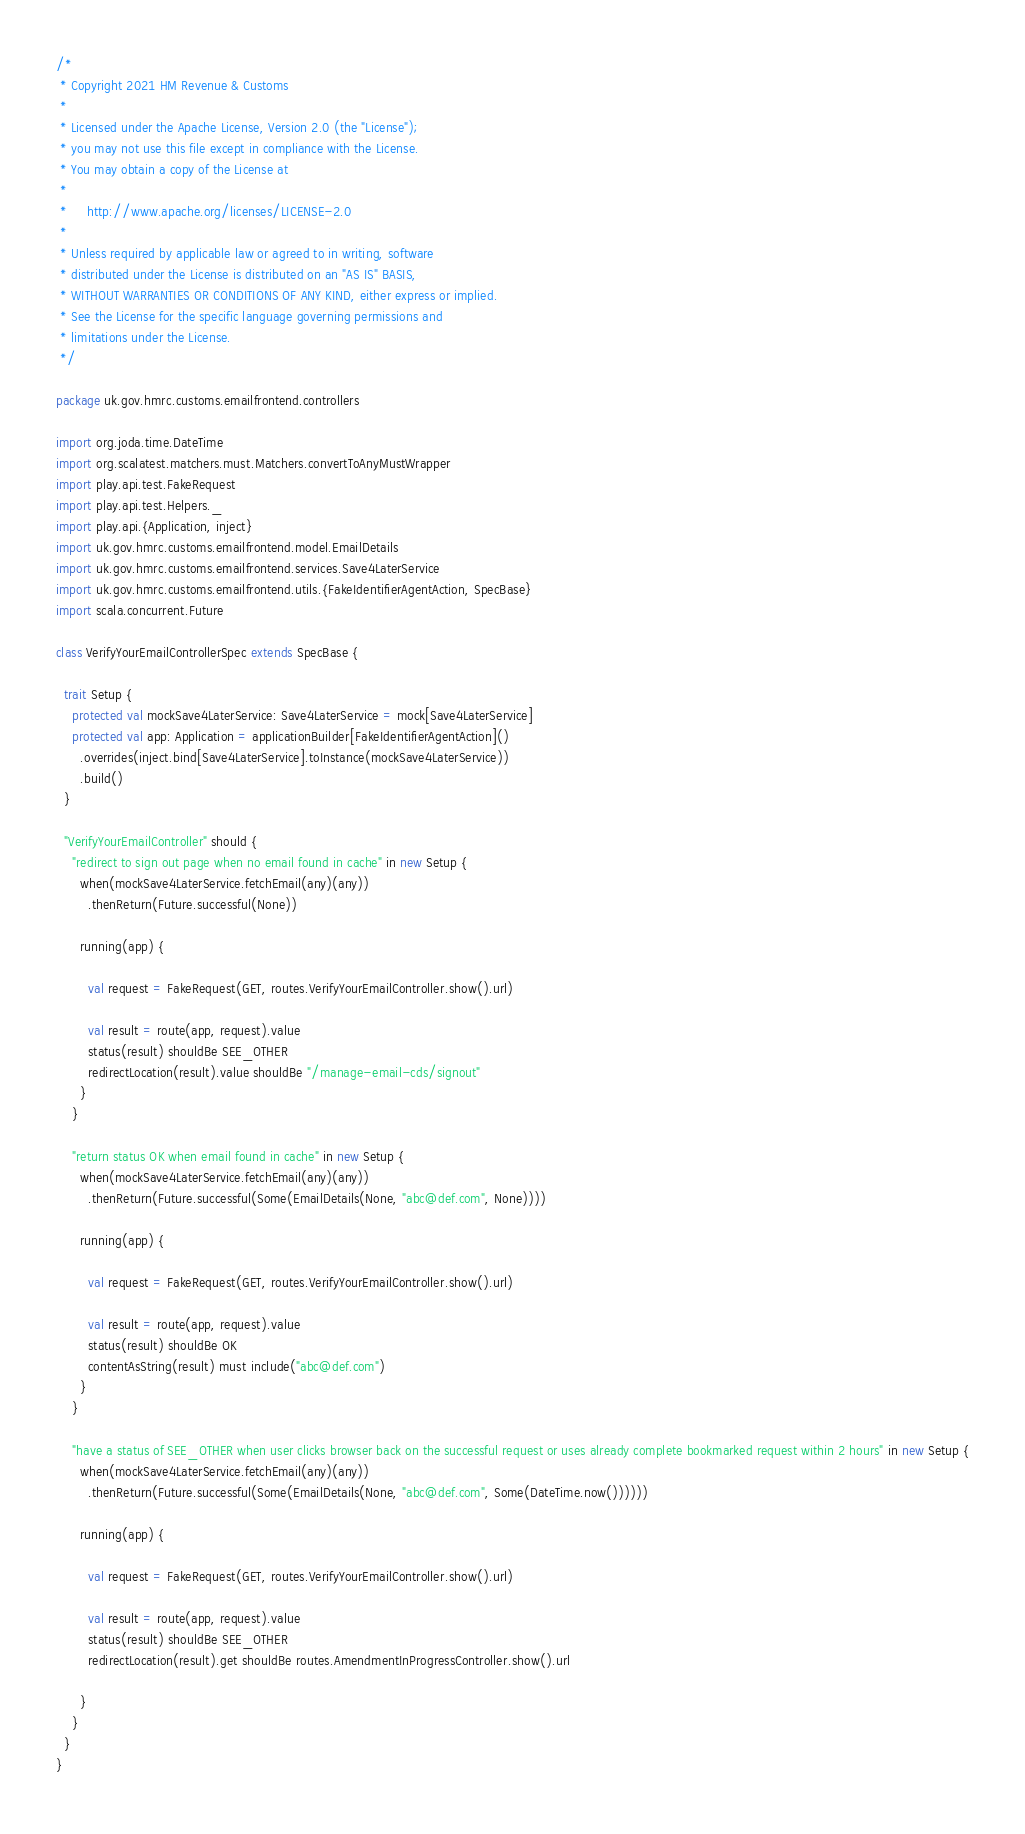Convert code to text. <code><loc_0><loc_0><loc_500><loc_500><_Scala_>/*
 * Copyright 2021 HM Revenue & Customs
 *
 * Licensed under the Apache License, Version 2.0 (the "License");
 * you may not use this file except in compliance with the License.
 * You may obtain a copy of the License at
 *
 *     http://www.apache.org/licenses/LICENSE-2.0
 *
 * Unless required by applicable law or agreed to in writing, software
 * distributed under the License is distributed on an "AS IS" BASIS,
 * WITHOUT WARRANTIES OR CONDITIONS OF ANY KIND, either express or implied.
 * See the License for the specific language governing permissions and
 * limitations under the License.
 */

package uk.gov.hmrc.customs.emailfrontend.controllers

import org.joda.time.DateTime
import org.scalatest.matchers.must.Matchers.convertToAnyMustWrapper
import play.api.test.FakeRequest
import play.api.test.Helpers._
import play.api.{Application, inject}
import uk.gov.hmrc.customs.emailfrontend.model.EmailDetails
import uk.gov.hmrc.customs.emailfrontend.services.Save4LaterService
import uk.gov.hmrc.customs.emailfrontend.utils.{FakeIdentifierAgentAction, SpecBase}
import scala.concurrent.Future

class VerifyYourEmailControllerSpec extends SpecBase {

  trait Setup {
    protected val mockSave4LaterService: Save4LaterService = mock[Save4LaterService]
    protected val app: Application = applicationBuilder[FakeIdentifierAgentAction]()
      .overrides(inject.bind[Save4LaterService].toInstance(mockSave4LaterService))
      .build()
  }

  "VerifyYourEmailController" should {
    "redirect to sign out page when no email found in cache" in new Setup {
      when(mockSave4LaterService.fetchEmail(any)(any))
        .thenReturn(Future.successful(None))

      running(app) {

        val request = FakeRequest(GET, routes.VerifyYourEmailController.show().url)

        val result = route(app, request).value
        status(result) shouldBe SEE_OTHER
        redirectLocation(result).value shouldBe "/manage-email-cds/signout"
      }
    }

    "return status OK when email found in cache" in new Setup {
      when(mockSave4LaterService.fetchEmail(any)(any))
        .thenReturn(Future.successful(Some(EmailDetails(None, "abc@def.com", None))))

      running(app) {

        val request = FakeRequest(GET, routes.VerifyYourEmailController.show().url)

        val result = route(app, request).value
        status(result) shouldBe OK
        contentAsString(result) must include("abc@def.com")
      }
    }

    "have a status of SEE_OTHER when user clicks browser back on the successful request or uses already complete bookmarked request within 2 hours" in new Setup {
      when(mockSave4LaterService.fetchEmail(any)(any))
        .thenReturn(Future.successful(Some(EmailDetails(None, "abc@def.com", Some(DateTime.now())))))

      running(app) {

        val request = FakeRequest(GET, routes.VerifyYourEmailController.show().url)

        val result = route(app, request).value
        status(result) shouldBe SEE_OTHER
        redirectLocation(result).get shouldBe routes.AmendmentInProgressController.show().url

      }
    }
  }
}
</code> 